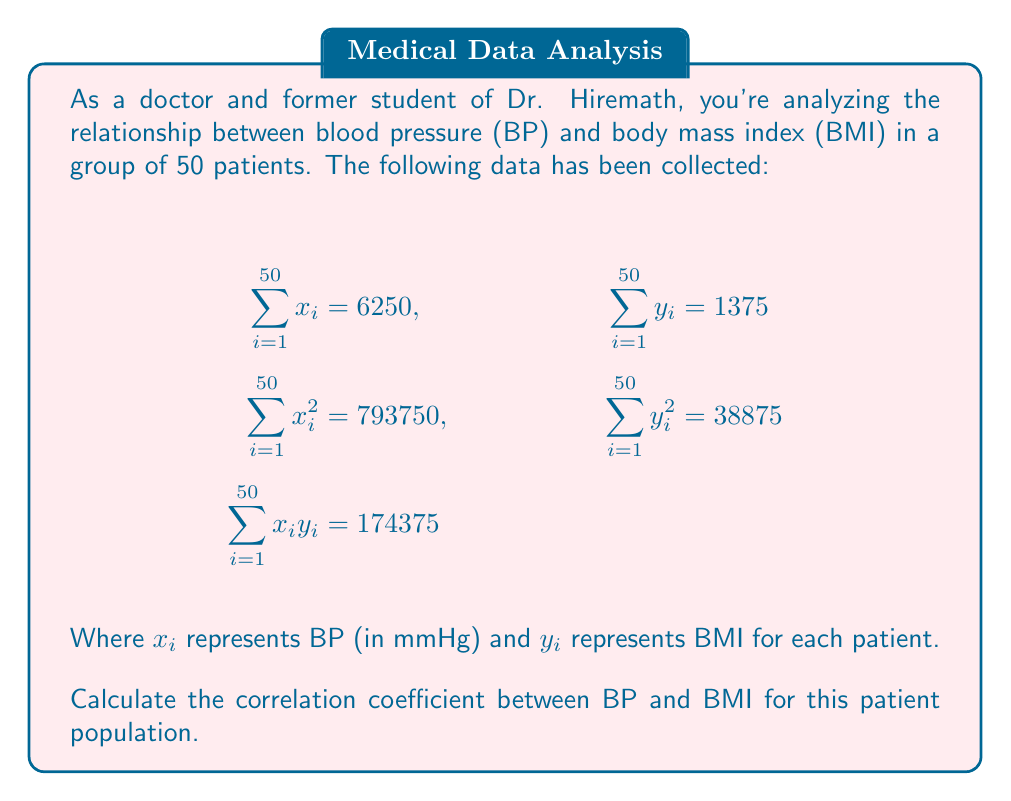What is the answer to this math problem? To calculate the correlation coefficient, we'll use the formula:

$$r = \frac{n\sum x_iy_i - (\sum x_i)(\sum y_i)}{\sqrt{[n\sum x_i^2 - (\sum x_i)^2][n\sum y_i^2 - (\sum y_i)^2]}}$$

Where $n$ is the number of patients (50 in this case).

Step 1: Calculate $n\sum x_iy_i$
$50 * 174375 = 8718750$

Step 2: Calculate $(\sum x_i)(\sum y_i)$
$6250 * 1375 = 8593750$

Step 3: Calculate the numerator
$8718750 - 8593750 = 125000$

Step 4: Calculate $n\sum x_i^2$ and $(\sum x_i)^2$
$50 * 793750 = 39687500$
$6250^2 = 39062500$

Step 5: Calculate $n\sum y_i^2$ and $(\sum y_i)^2$
$50 * 38875 = 1943750$
$1375^2 = 1890625$

Step 6: Calculate the denominator
$\sqrt{(39687500 - 39062500)(1943750 - 1890625)}$
$= \sqrt{(625000)(53125)}$
$= \sqrt{33203125000}$
$= 182217.36$

Step 7: Calculate the correlation coefficient
$r = \frac{125000}{182217.36} = 0.6859$

Therefore, the correlation coefficient between BP and BMI is approximately 0.6859.
Answer: $r \approx 0.6859$ 